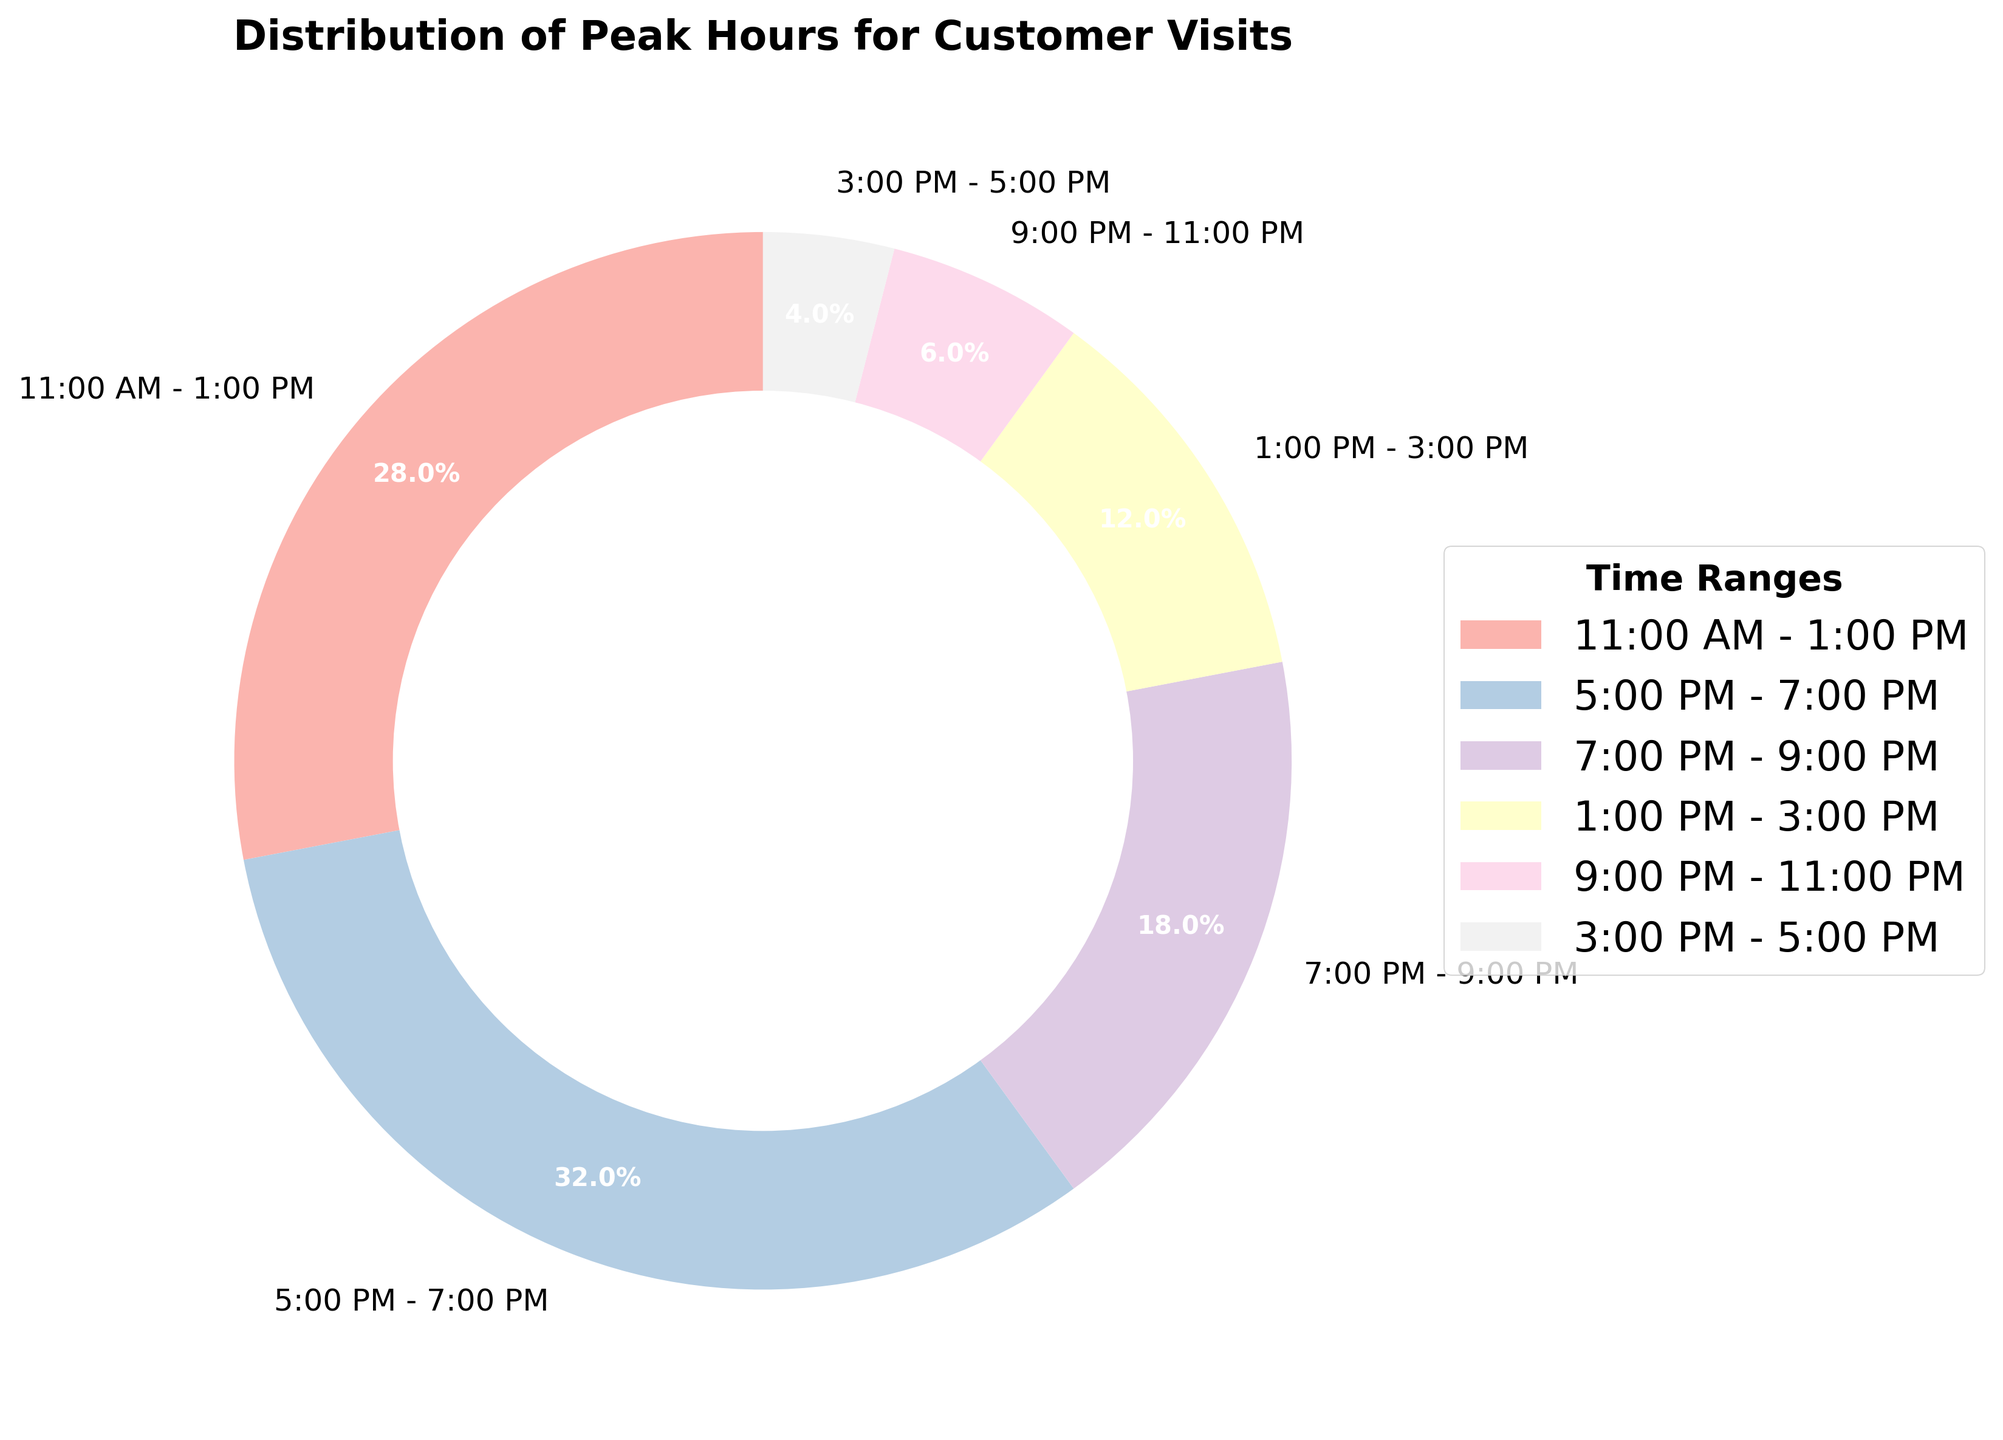What are the two peak time ranges with the highest percentage of customer visits? The figure shows different time ranges with corresponding percentages. By comparing these percentages, we can identify that 5:00 PM - 7:00 PM (32%) and 11:00 AM - 1:00 PM (28%) have the highest percentages.
Answer: 5:00 PM - 7:00 PM and 11:00 AM - 1:00 PM What is the total percentage for the time ranges between 5:00 PM and 9:00 PM? The percentages for the time ranges 5:00 PM - 7:00 PM and 7:00 PM - 9:00 PM are 32% and 18% respectively. Summing these values gives 32 + 18 = 50%.
Answer: 50% What is the combined percentage of customer visits for the morning and afternoon periods (11:00 AM - 3:00 PM)? The morning and afternoon periods cover 11:00 AM - 1:00 PM (28%) and 1:00 PM - 3:00 PM (12%). Summing these percentages yields 28 + 12 = 40%.
Answer: 40% Which time range has the lowest percentage of customer visits? By examining the figure, it is clear that the time range 3:00 PM - 5:00 PM has the lowest percentage of 4%.
Answer: 3:00 PM - 5:00 PM Are there more customer visits between 1:00 PM and 5:00 PM, or between 7:00 PM and 11:00 PM? The summed percentages for 1:00 PM - 3:00 PM and 3:00 PM - 5:00 PM are 12% and 4%, totaling 16%. The summed percentages for 7:00 PM - 9:00 PM and 9:00 PM - 11:00 PM are 18% and 6%, totaling 24%. Hence, there are more visits between 7:00 PM - 11:00 PM.
Answer: 7:00 PM - 11:00 PM What percentage of customer visits occurs after 5:00 PM? The time ranges post 5:00 PM are 5:00 PM - 7:00 PM (32%), 7:00 PM - 9:00 PM (18%), and 9:00 PM - 11:00 PM (6%). Summing these gives 32 + 18 + 6 = 56%.
Answer: 56% How does the percentage of customer visits between 11:00 AM and 1:00 PM compare to that between 7:00 PM and 9:00 PM? The percentage for 11:00 AM - 1:00 PM is 28% and for 7:00 PM - 9:00 PM is 18%. Therefore, the earlier time range has a higher percentage.
Answer: 11:00 AM - 1:00 PM has a higher percentage Is there any time range that has a customer visit percentage greater than 30%? Observing the percentages, the 5:00 PM - 7:00 PM time range is the only one with a percentage greater than 30%, specifically 32%.
Answer: Yes, 5:00 PM - 7:00 PM Which time range has a higher percentage of customer visits: 1:00 PM - 3:00 PM or 3:00 PM - 5:00 PM? By looking at the figure, the percentage for 1:00 PM - 3:00 PM is 12% while for 3:00 PM - 5:00 PM it is 4%. Thus, 1:00 PM - 3:00 PM has a higher percentage.
Answer: 1:00 PM - 3:00 PM What is the difference in customer visit percentages between the peak hour (5:00 PM - 7:00 PM) and the lowest hour (3:00 PM - 5:00 PM)? The peak hour 5:00 PM - 7:00 PM has a percentage of 32% and the lowest hour 3:00 PM - 5:00 PM has 4%. The difference between them is 32 - 4 = 28%.
Answer: 28% 